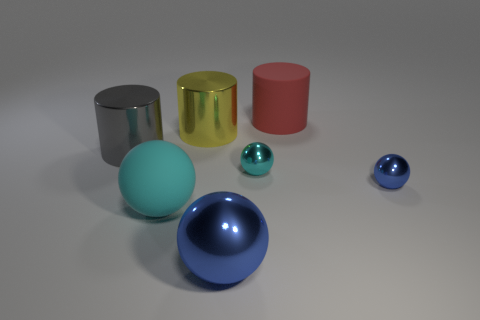Add 2 cylinders. How many objects exist? 9 Subtract all cylinders. How many objects are left? 4 Subtract 0 purple cylinders. How many objects are left? 7 Subtract all large yellow objects. Subtract all big cyan matte balls. How many objects are left? 5 Add 1 small metal spheres. How many small metal spheres are left? 3 Add 1 yellow cylinders. How many yellow cylinders exist? 2 